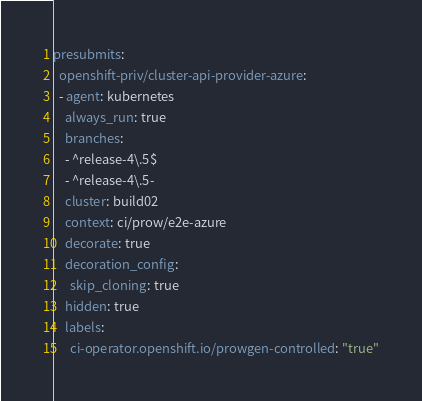Convert code to text. <code><loc_0><loc_0><loc_500><loc_500><_YAML_>presubmits:
  openshift-priv/cluster-api-provider-azure:
  - agent: kubernetes
    always_run: true
    branches:
    - ^release-4\.5$
    - ^release-4\.5-
    cluster: build02
    context: ci/prow/e2e-azure
    decorate: true
    decoration_config:
      skip_cloning: true
    hidden: true
    labels:
      ci-operator.openshift.io/prowgen-controlled: "true"</code> 